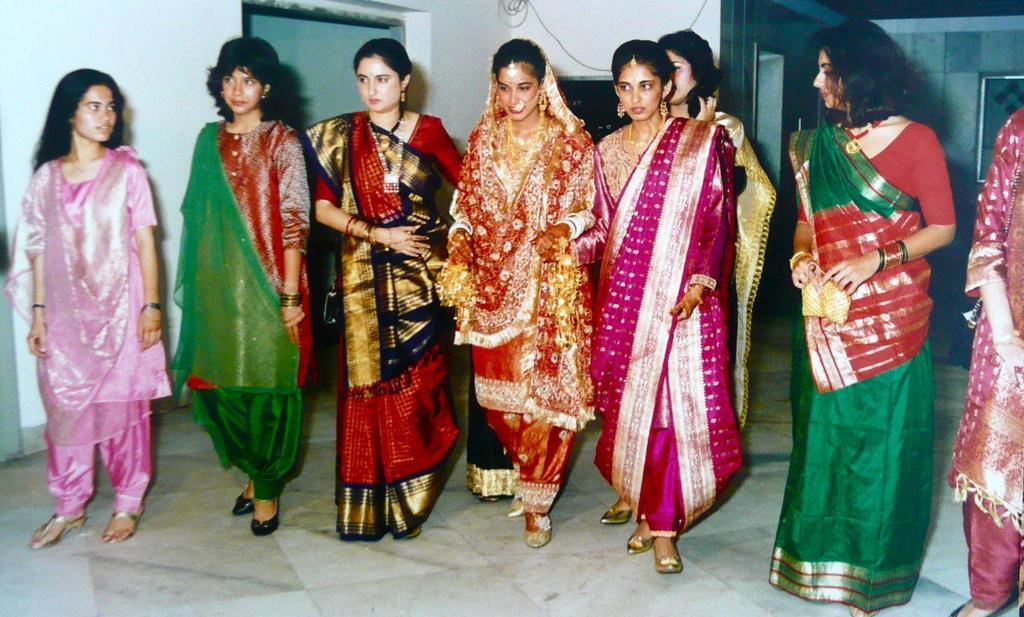How would you summarize this image in a sentence or two? In the foreground of this image, there are eight women standing on the floor in ethnic wear. In the background, there is a wall, an entrance and a frame on the wall. 